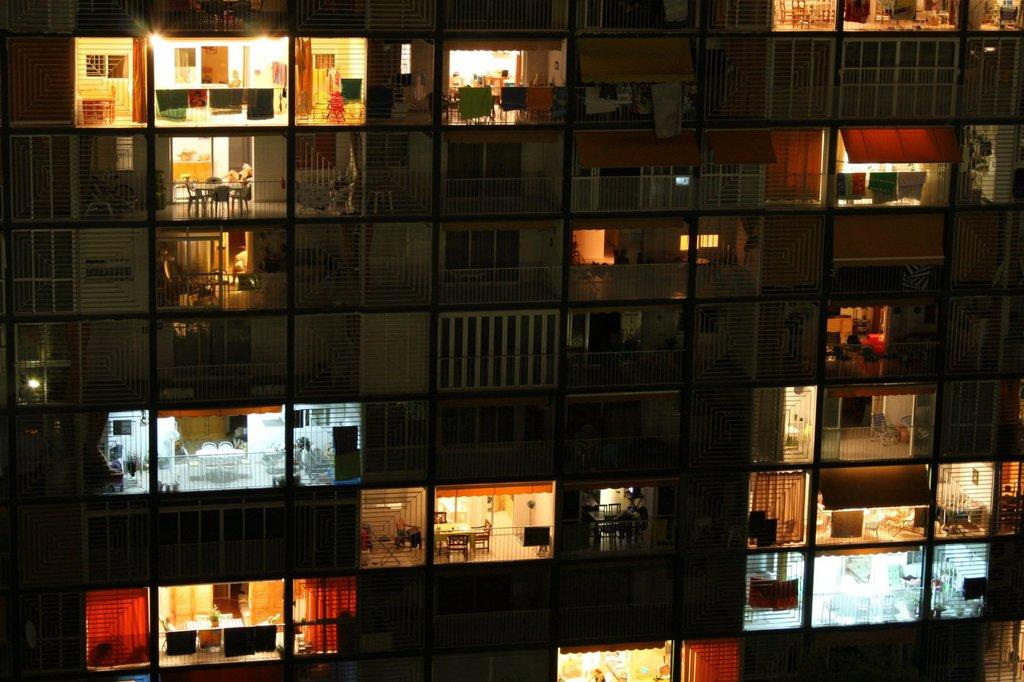What type of structure is shown in the image? There is a building in the image. What architectural features can be seen on the building? Balconies, walls, railings, and tables are visible in the image. What objects are present on the balconies? Clothes and chairs are visible on the balconies. Are there any light sources in the image? Yes, lights are present in the image. Can you describe any unspecified objects in the image? There are some unspecified objects in the image, but their nature cannot be determined from the provided facts. How many cows are visible on the balconies in the image? There are no cows visible on the balconies in the image. What type of stick is being used to stir the lights in the image? There is no stick present in the image, and the lights do not require stirring. 